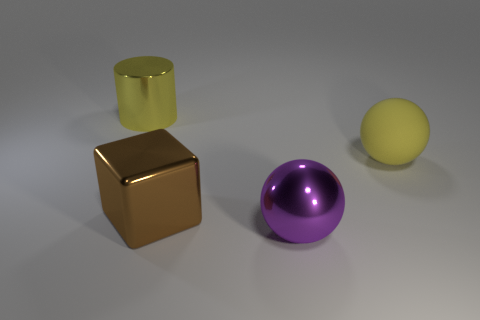There is a ball that is the same color as the large cylinder; what size is it? The ball that shares the same color as the large cylinder is itself of a large size, similar to the cylinder in proportion to its relative dimensions. 